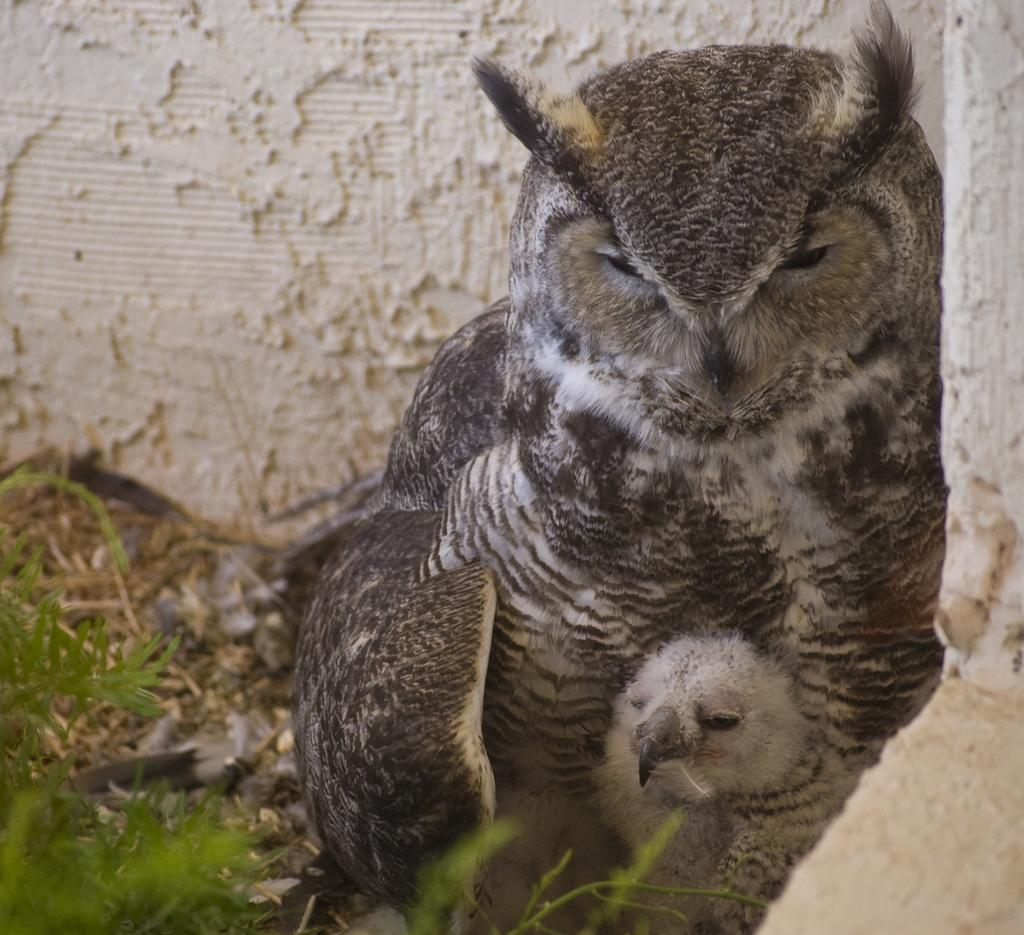What type of bird can be seen in the image? There is an owl and an owlet in the image. What is the setting of the image? Leaves are present in the image, suggesting a natural environment. What type of structure is visible in the image? There is a wall in the image. What type of soap is being used to clean the owl in the image? There is no soap or cleaning activity depicted in the image; it simply shows an owl and an owlet in a natural setting. 